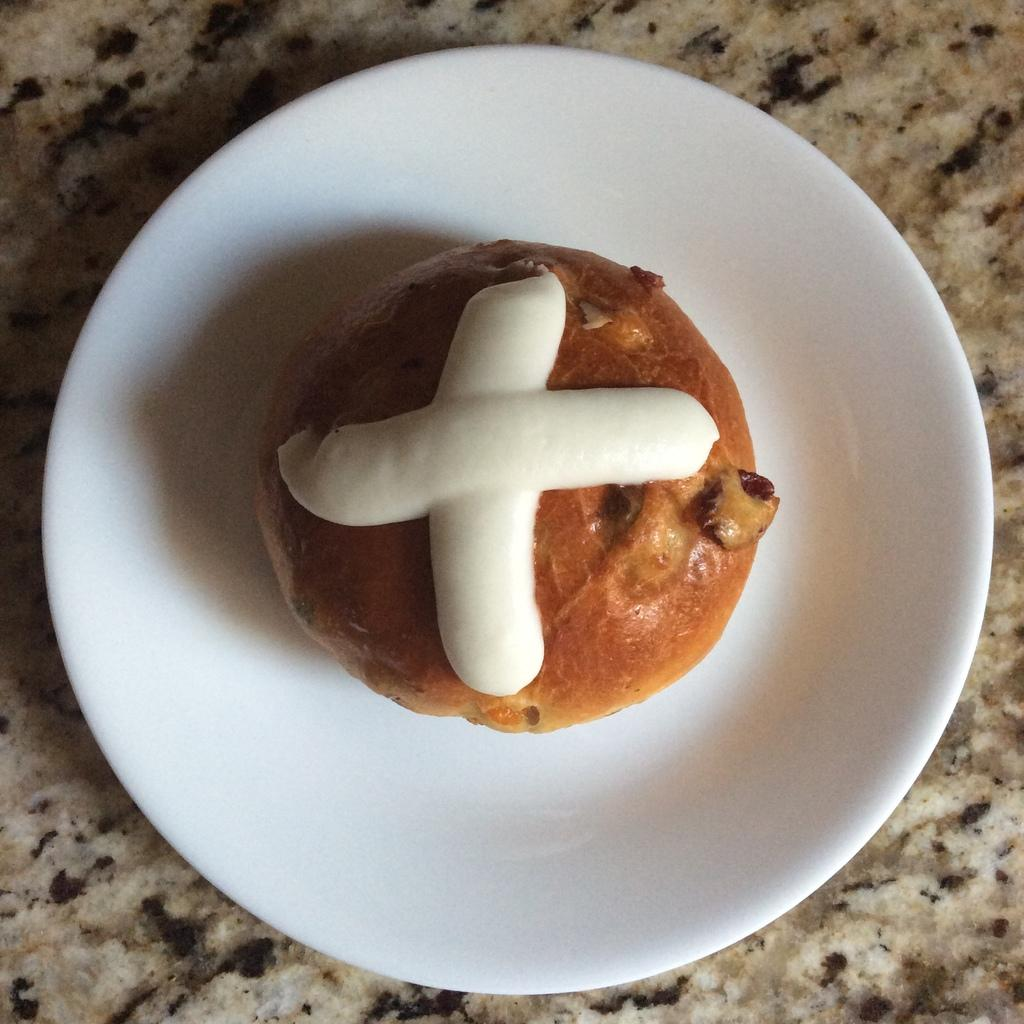What is the main subject of the image? The main subject of the image is food. How is the food presented in the image? The food is in a white-colored bowl. What type of experience can be gained from the dock in the image? There is no dock present in the image; it only features food in a white-colored bowl. 